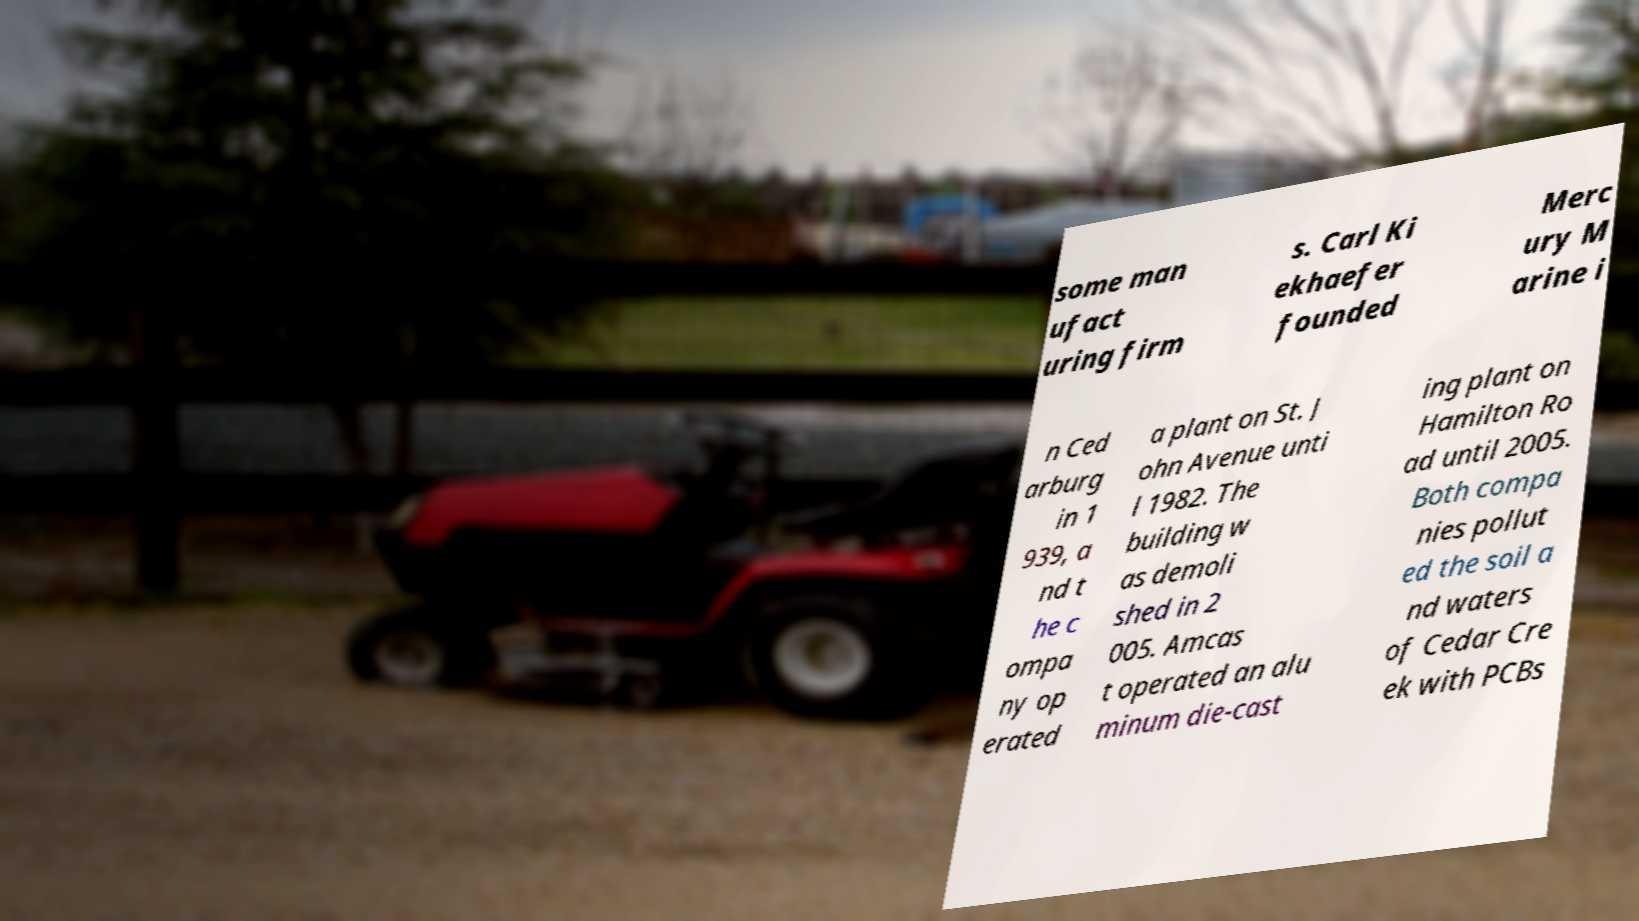Could you assist in decoding the text presented in this image and type it out clearly? some man ufact uring firm s. Carl Ki ekhaefer founded Merc ury M arine i n Ced arburg in 1 939, a nd t he c ompa ny op erated a plant on St. J ohn Avenue unti l 1982. The building w as demoli shed in 2 005. Amcas t operated an alu minum die-cast ing plant on Hamilton Ro ad until 2005. Both compa nies pollut ed the soil a nd waters of Cedar Cre ek with PCBs 